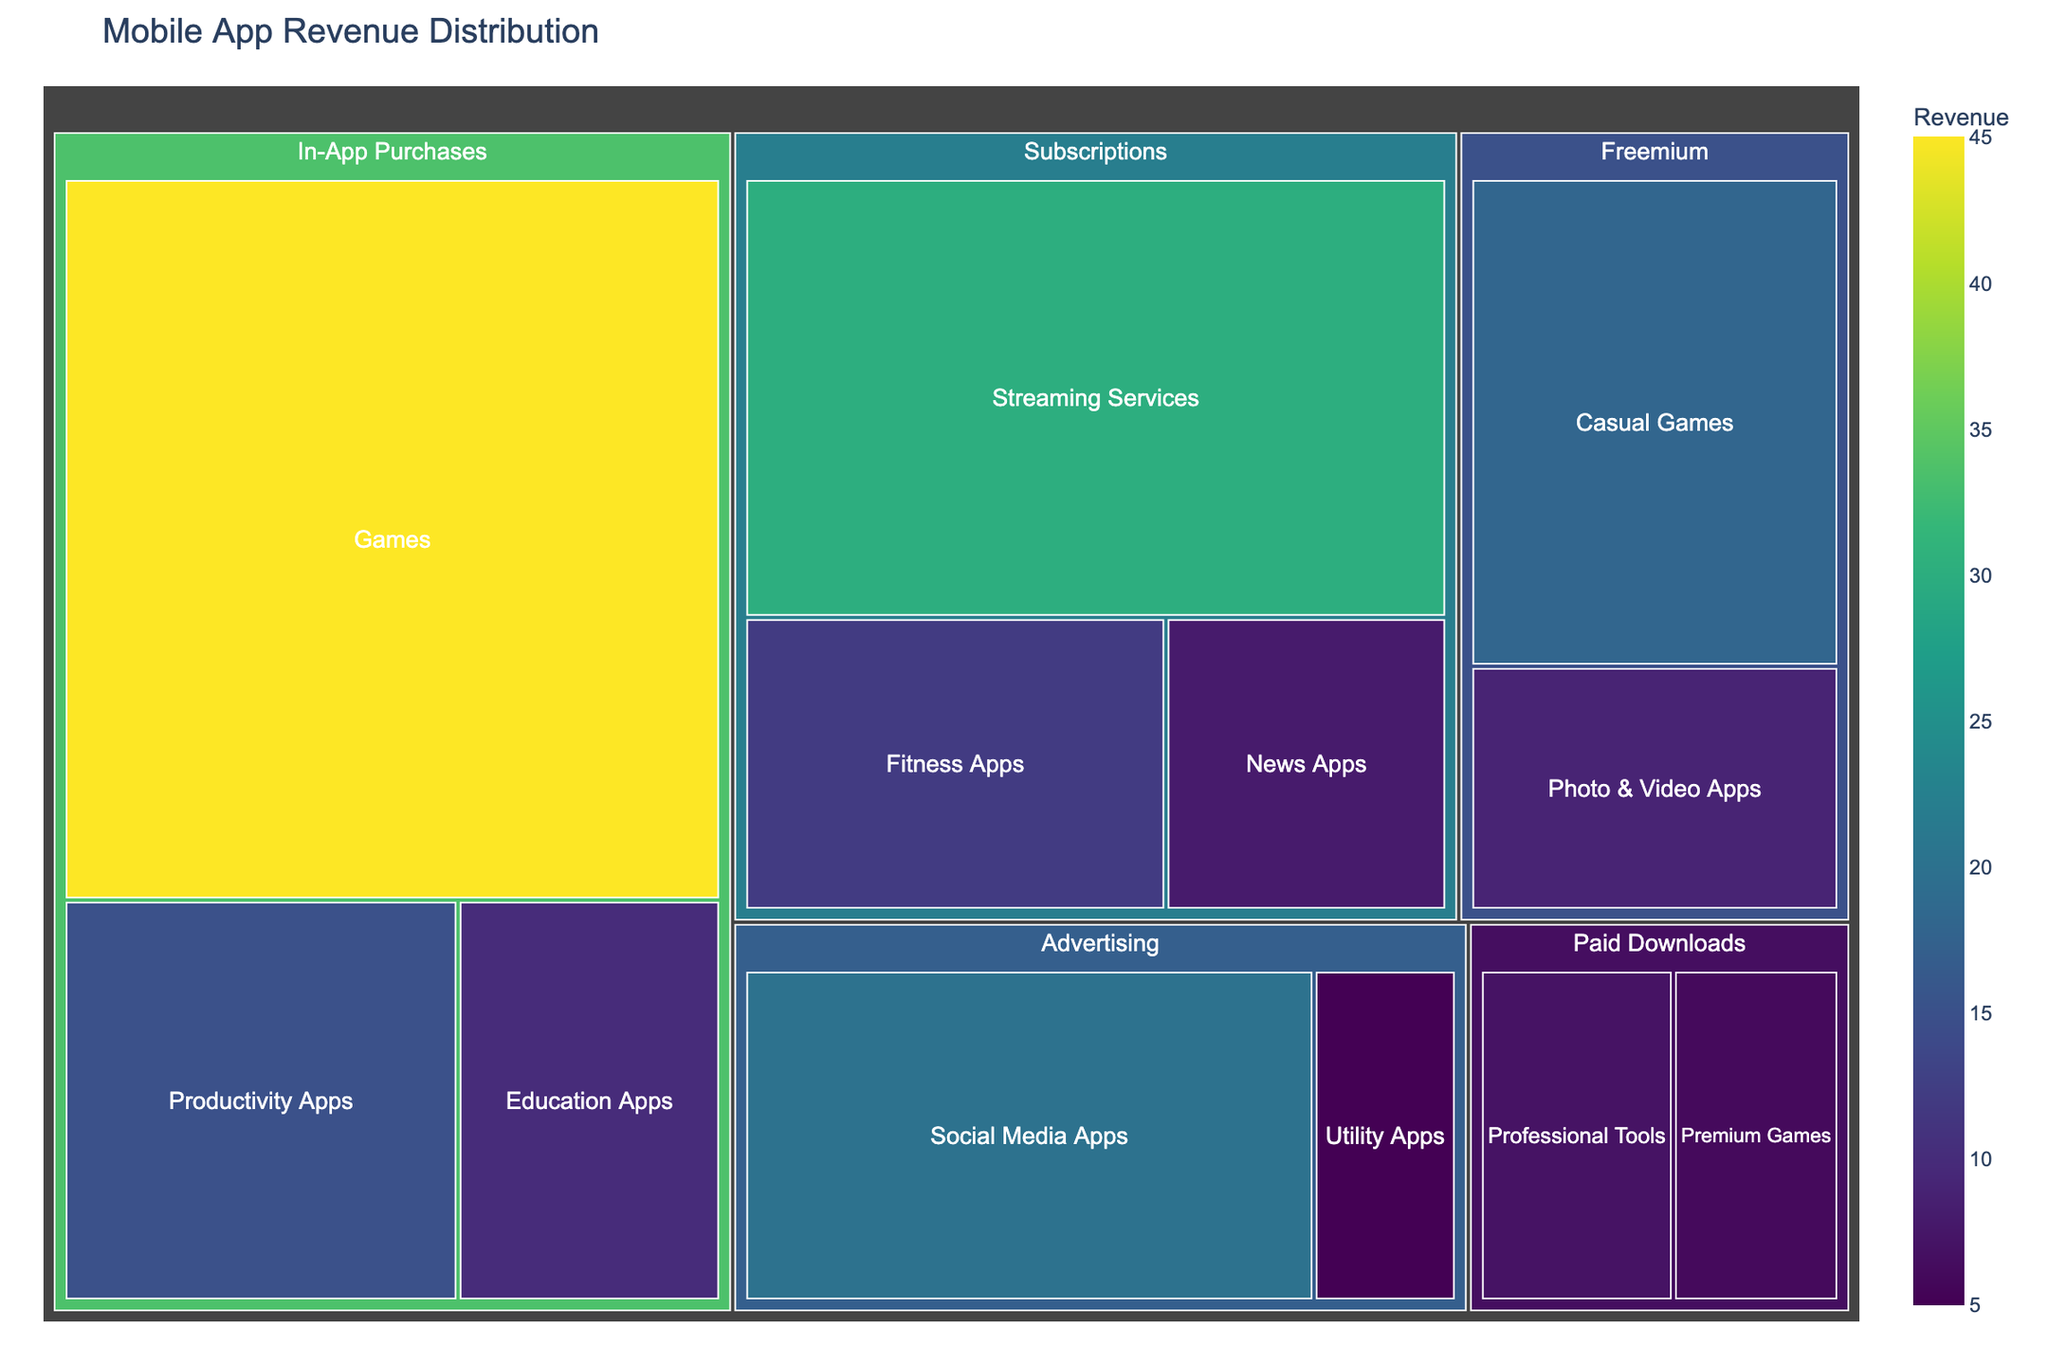What is the title of the treemap? The title of the treemap is located at the top of the image and it summarizes the topic depicted in the treemap.
Answer: Mobile App Revenue Distribution Which category has the highest revenue in the treemap? By examining the proportion of each category in the treemap, the Game subcategory under In-App Purchases is visibly the largest, indicating the highest revenue.
Answer: In-App Purchases Which subcategory within Subscriptions has the smallest revenue? By observing the treemap's color shading and tile size within the Subscriptions category, the smallest subcategory box indicates the lowest revenue.
Answer: News Apps What is the total revenue for the Advertising category? Add up the revenue values of the subcategories under the Advertising category which are Social Media Apps (20) and Utility Apps (5). Sum is 20 + 5.
Answer: 25 How does the revenue for Fitness Apps compare to that of Education Apps? Locate both subcategories under their respective categories (Subscriptions for Fitness Apps and In-App Purchases for Education Apps) and compare their values. Fitness Apps have a value of 12 while Education Apps have a value of 10.
Answer: Fitness Apps generate more revenue than Education Apps What subcategory within the Freemium category has higher revenue? Compare the values of the subcategories under Freemium: Casual Games (18) and Photo & Video Apps (9). The larger value indicates higher revenue.
Answer: Casual Games Which monetization model has more categories, Subscriptions or Paid Downloads? Count the number of subcategories within each main category. Subscriptions have 3 subcategories (Streaming Services, Fitness Apps, News Apps), while Paid Downloads have 2 subcategories (Professional Tools, Premium Games).
Answer: Subscriptions What is the combined revenue of all subcategories under Subscriptions? Add the revenue values of all subcategories within Subscriptions: Streaming Services (30), Fitness Apps (12), and News Apps (8). The sum is 30 + 12 + 8.
Answer: 50 How much more revenue do Games generate from In-App Purchases compared to Premium Games under Paid Downloads? Subtract the revenue of Premium Games (6) from Games within In-App Purchases (45). The difference is 45 - 6.
Answer: 39 Which has more revenue: Freemium or Advertising? Calculate the total revenue of each main category by summing up their subcategories. Freemium: Casual Games (18) + Photo & Video Apps (9) = 27. Advertising: Social Media Apps (20) + Utility Apps (5) = 25. Compare the totals.
Answer: Freemium has more revenue than Advertising 